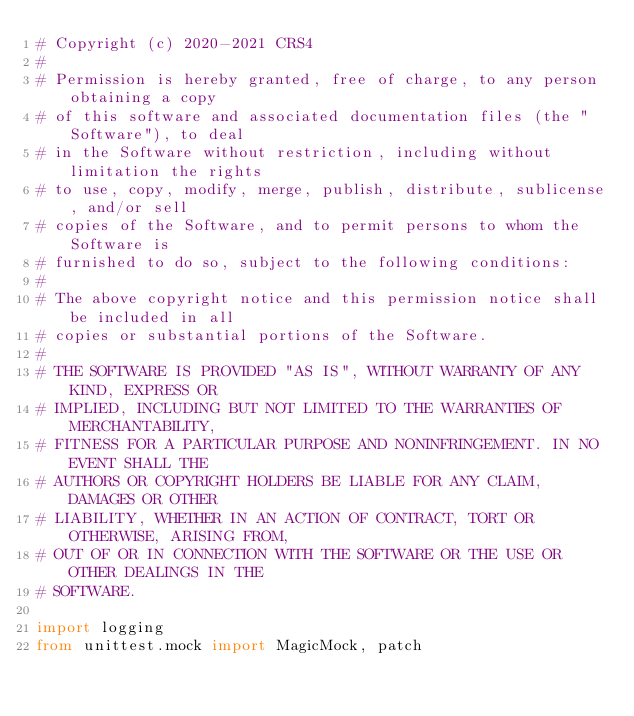<code> <loc_0><loc_0><loc_500><loc_500><_Python_># Copyright (c) 2020-2021 CRS4
#
# Permission is hereby granted, free of charge, to any person obtaining a copy
# of this software and associated documentation files (the "Software"), to deal
# in the Software without restriction, including without limitation the rights
# to use, copy, modify, merge, publish, distribute, sublicense, and/or sell
# copies of the Software, and to permit persons to whom the Software is
# furnished to do so, subject to the following conditions:
#
# The above copyright notice and this permission notice shall be included in all
# copies or substantial portions of the Software.
#
# THE SOFTWARE IS PROVIDED "AS IS", WITHOUT WARRANTY OF ANY KIND, EXPRESS OR
# IMPLIED, INCLUDING BUT NOT LIMITED TO THE WARRANTIES OF MERCHANTABILITY,
# FITNESS FOR A PARTICULAR PURPOSE AND NONINFRINGEMENT. IN NO EVENT SHALL THE
# AUTHORS OR COPYRIGHT HOLDERS BE LIABLE FOR ANY CLAIM, DAMAGES OR OTHER
# LIABILITY, WHETHER IN AN ACTION OF CONTRACT, TORT OR OTHERWISE, ARISING FROM,
# OUT OF OR IN CONNECTION WITH THE SOFTWARE OR THE USE OR OTHER DEALINGS IN THE
# SOFTWARE.

import logging
from unittest.mock import MagicMock, patch
</code> 